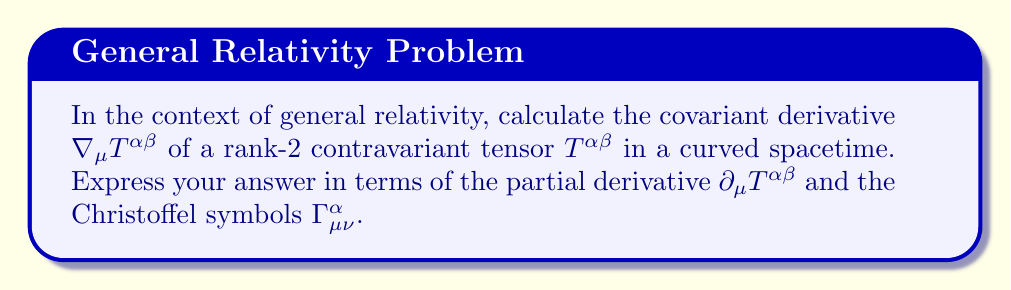Provide a solution to this math problem. To calculate the covariant derivative of a rank-2 contravariant tensor in general relativity, we follow these steps:

1) The general form of the covariant derivative for a rank-2 contravariant tensor is:

   $$\nabla_\mu T^{\alpha\beta} = \partial_\mu T^{\alpha\beta} + \Gamma^\alpha_{\mu\nu} T^{\nu\beta} + \Gamma^\beta_{\mu\nu} T^{\alpha\nu}$$

2) Let's break down each term:
   
   a) $\partial_\mu T^{\alpha\beta}$ is the partial derivative of the tensor with respect to $x^\mu$.
   
   b) $\Gamma^\alpha_{\mu\nu} T^{\nu\beta}$ accounts for the change in the basis vector $\mathbf{e}_\alpha$ as we move in the $\mu$ direction.
   
   c) $\Gamma^\beta_{\mu\nu} T^{\alpha\nu}$ accounts for the change in the basis vector $\mathbf{e}_\beta$ as we move in the $\mu$ direction.

3) The Christoffel symbols $\Gamma^\alpha_{\mu\nu}$ represent the connection coefficients in curved spacetime. They describe how basis vectors change from point to point.

4) Note that we sum over repeated indices (Einstein summation convention). In this case, we sum over $\nu$ in the last two terms.

5) This formula ensures that the covariant derivative transforms as a tensor, unlike the partial derivative which does not transform covariantly in curved spacetime.

6) The presence of the Christoffel symbols in this expression is what distinguishes the covariant derivative from the ordinary partial derivative, and it's what allows us to perform calculus in curved spacetime.
Answer: $$\nabla_\mu T^{\alpha\beta} = \partial_\mu T^{\alpha\beta} + \Gamma^\alpha_{\mu\nu} T^{\nu\beta} + \Gamma^\beta_{\mu\nu} T^{\alpha\nu}$$ 